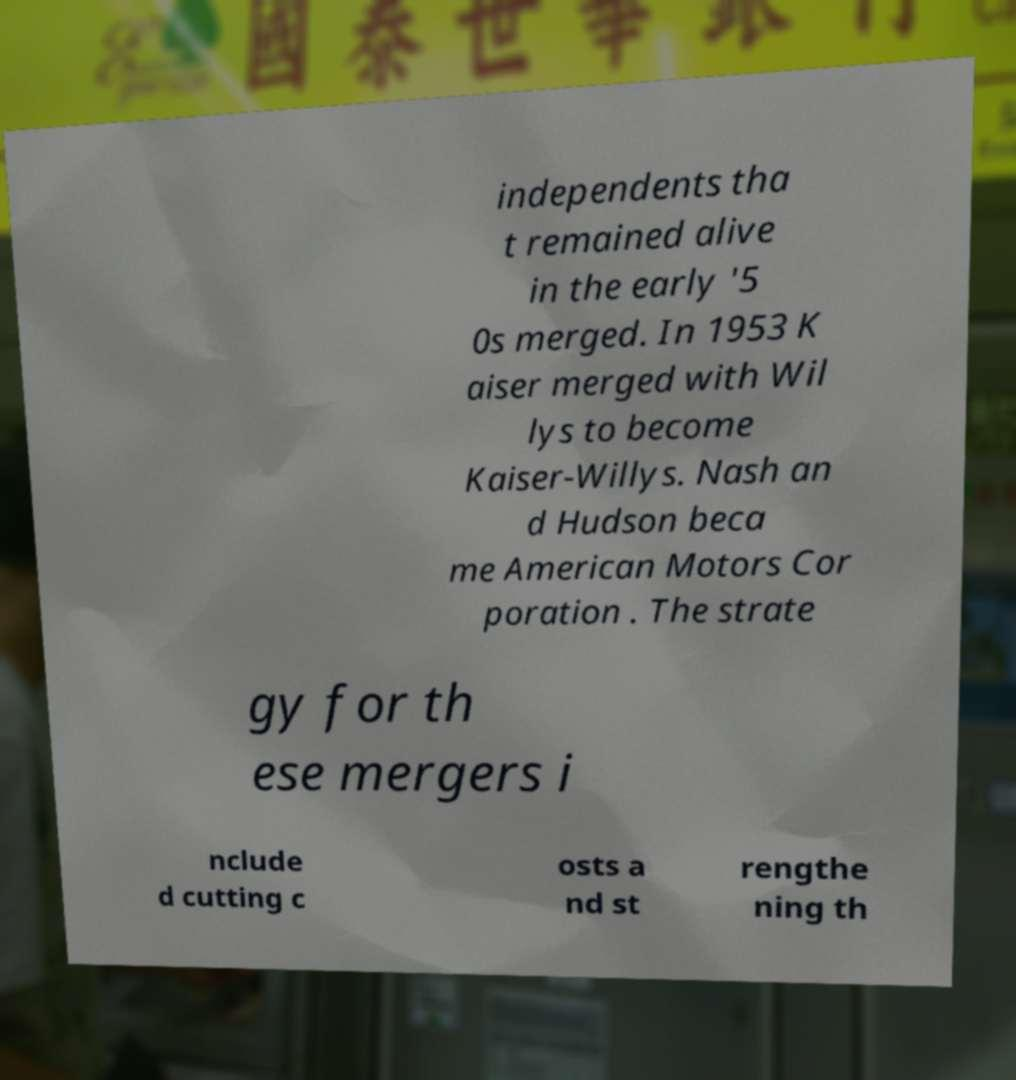For documentation purposes, I need the text within this image transcribed. Could you provide that? independents tha t remained alive in the early '5 0s merged. In 1953 K aiser merged with Wil lys to become Kaiser-Willys. Nash an d Hudson beca me American Motors Cor poration . The strate gy for th ese mergers i nclude d cutting c osts a nd st rengthe ning th 